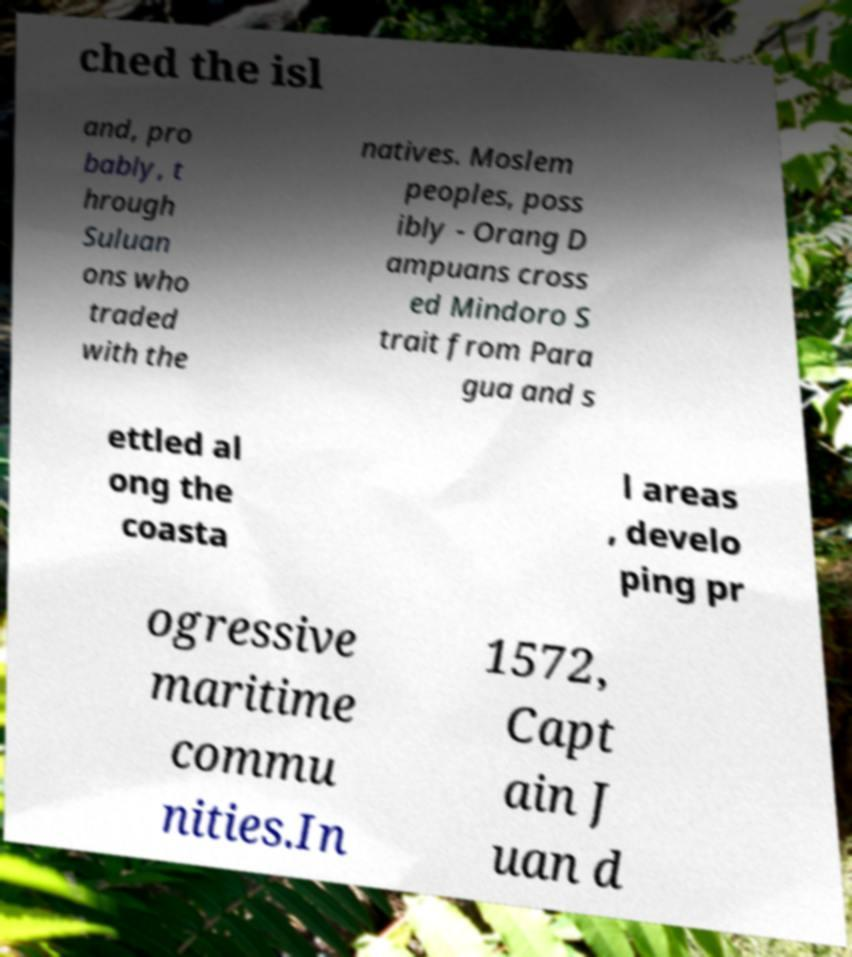For documentation purposes, I need the text within this image transcribed. Could you provide that? ched the isl and, pro bably, t hrough Suluan ons who traded with the natives. Moslem peoples, poss ibly - Orang D ampuans cross ed Mindoro S trait from Para gua and s ettled al ong the coasta l areas , develo ping pr ogressive maritime commu nities.In 1572, Capt ain J uan d 